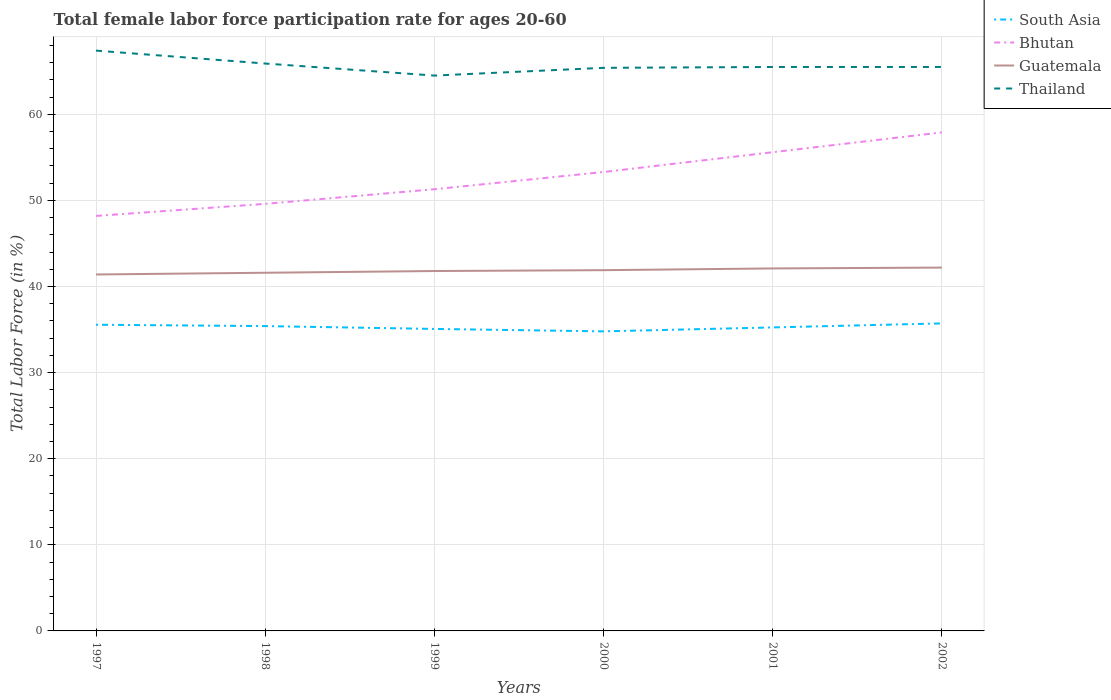How many different coloured lines are there?
Your answer should be compact. 4. Is the number of lines equal to the number of legend labels?
Your answer should be very brief. Yes. Across all years, what is the maximum female labor force participation rate in Bhutan?
Offer a very short reply. 48.2. What is the total female labor force participation rate in South Asia in the graph?
Make the answer very short. -0.18. What is the difference between the highest and the second highest female labor force participation rate in South Asia?
Offer a terse response. 0.92. What is the difference between the highest and the lowest female labor force participation rate in Thailand?
Keep it short and to the point. 2. Is the female labor force participation rate in Thailand strictly greater than the female labor force participation rate in Guatemala over the years?
Your response must be concise. No. Are the values on the major ticks of Y-axis written in scientific E-notation?
Your response must be concise. No. Does the graph contain grids?
Ensure brevity in your answer.  Yes. Where does the legend appear in the graph?
Offer a very short reply. Top right. How many legend labels are there?
Offer a very short reply. 4. How are the legend labels stacked?
Ensure brevity in your answer.  Vertical. What is the title of the graph?
Offer a terse response. Total female labor force participation rate for ages 20-60. What is the label or title of the X-axis?
Your answer should be very brief. Years. What is the Total Labor Force (in %) in South Asia in 1997?
Make the answer very short. 35.56. What is the Total Labor Force (in %) of Bhutan in 1997?
Keep it short and to the point. 48.2. What is the Total Labor Force (in %) in Guatemala in 1997?
Offer a terse response. 41.4. What is the Total Labor Force (in %) of Thailand in 1997?
Your response must be concise. 67.4. What is the Total Labor Force (in %) of South Asia in 1998?
Keep it short and to the point. 35.4. What is the Total Labor Force (in %) of Bhutan in 1998?
Provide a short and direct response. 49.6. What is the Total Labor Force (in %) in Guatemala in 1998?
Offer a terse response. 41.6. What is the Total Labor Force (in %) in Thailand in 1998?
Your response must be concise. 65.9. What is the Total Labor Force (in %) of South Asia in 1999?
Offer a very short reply. 35.07. What is the Total Labor Force (in %) of Bhutan in 1999?
Keep it short and to the point. 51.3. What is the Total Labor Force (in %) in Guatemala in 1999?
Give a very brief answer. 41.8. What is the Total Labor Force (in %) in Thailand in 1999?
Keep it short and to the point. 64.5. What is the Total Labor Force (in %) in South Asia in 2000?
Offer a terse response. 34.79. What is the Total Labor Force (in %) of Bhutan in 2000?
Your response must be concise. 53.3. What is the Total Labor Force (in %) of Guatemala in 2000?
Give a very brief answer. 41.9. What is the Total Labor Force (in %) of Thailand in 2000?
Make the answer very short. 65.4. What is the Total Labor Force (in %) of South Asia in 2001?
Offer a very short reply. 35.25. What is the Total Labor Force (in %) of Bhutan in 2001?
Keep it short and to the point. 55.6. What is the Total Labor Force (in %) of Guatemala in 2001?
Make the answer very short. 42.1. What is the Total Labor Force (in %) of Thailand in 2001?
Ensure brevity in your answer.  65.5. What is the Total Labor Force (in %) of South Asia in 2002?
Make the answer very short. 35.72. What is the Total Labor Force (in %) of Bhutan in 2002?
Offer a terse response. 57.9. What is the Total Labor Force (in %) in Guatemala in 2002?
Keep it short and to the point. 42.2. What is the Total Labor Force (in %) in Thailand in 2002?
Your answer should be very brief. 65.5. Across all years, what is the maximum Total Labor Force (in %) of South Asia?
Provide a short and direct response. 35.72. Across all years, what is the maximum Total Labor Force (in %) in Bhutan?
Your response must be concise. 57.9. Across all years, what is the maximum Total Labor Force (in %) in Guatemala?
Ensure brevity in your answer.  42.2. Across all years, what is the maximum Total Labor Force (in %) of Thailand?
Provide a succinct answer. 67.4. Across all years, what is the minimum Total Labor Force (in %) of South Asia?
Make the answer very short. 34.79. Across all years, what is the minimum Total Labor Force (in %) in Bhutan?
Give a very brief answer. 48.2. Across all years, what is the minimum Total Labor Force (in %) in Guatemala?
Offer a very short reply. 41.4. Across all years, what is the minimum Total Labor Force (in %) in Thailand?
Your answer should be very brief. 64.5. What is the total Total Labor Force (in %) of South Asia in the graph?
Offer a terse response. 211.8. What is the total Total Labor Force (in %) in Bhutan in the graph?
Offer a very short reply. 315.9. What is the total Total Labor Force (in %) in Guatemala in the graph?
Your response must be concise. 251. What is the total Total Labor Force (in %) of Thailand in the graph?
Offer a terse response. 394.2. What is the difference between the Total Labor Force (in %) in South Asia in 1997 and that in 1998?
Ensure brevity in your answer.  0.16. What is the difference between the Total Labor Force (in %) of Guatemala in 1997 and that in 1998?
Give a very brief answer. -0.2. What is the difference between the Total Labor Force (in %) in Thailand in 1997 and that in 1998?
Offer a terse response. 1.5. What is the difference between the Total Labor Force (in %) in South Asia in 1997 and that in 1999?
Your answer should be very brief. 0.49. What is the difference between the Total Labor Force (in %) of Guatemala in 1997 and that in 1999?
Ensure brevity in your answer.  -0.4. What is the difference between the Total Labor Force (in %) in Thailand in 1997 and that in 1999?
Offer a very short reply. 2.9. What is the difference between the Total Labor Force (in %) of South Asia in 1997 and that in 2000?
Make the answer very short. 0.77. What is the difference between the Total Labor Force (in %) of Guatemala in 1997 and that in 2000?
Offer a terse response. -0.5. What is the difference between the Total Labor Force (in %) of South Asia in 1997 and that in 2001?
Your response must be concise. 0.31. What is the difference between the Total Labor Force (in %) in Bhutan in 1997 and that in 2001?
Make the answer very short. -7.4. What is the difference between the Total Labor Force (in %) in Guatemala in 1997 and that in 2001?
Keep it short and to the point. -0.7. What is the difference between the Total Labor Force (in %) of South Asia in 1997 and that in 2002?
Provide a short and direct response. -0.16. What is the difference between the Total Labor Force (in %) in Bhutan in 1997 and that in 2002?
Your answer should be compact. -9.7. What is the difference between the Total Labor Force (in %) of Thailand in 1997 and that in 2002?
Ensure brevity in your answer.  1.9. What is the difference between the Total Labor Force (in %) of South Asia in 1998 and that in 1999?
Keep it short and to the point. 0.33. What is the difference between the Total Labor Force (in %) of Bhutan in 1998 and that in 1999?
Keep it short and to the point. -1.7. What is the difference between the Total Labor Force (in %) of Thailand in 1998 and that in 1999?
Ensure brevity in your answer.  1.4. What is the difference between the Total Labor Force (in %) of South Asia in 1998 and that in 2000?
Your answer should be very brief. 0.61. What is the difference between the Total Labor Force (in %) in Bhutan in 1998 and that in 2000?
Ensure brevity in your answer.  -3.7. What is the difference between the Total Labor Force (in %) of Guatemala in 1998 and that in 2000?
Ensure brevity in your answer.  -0.3. What is the difference between the Total Labor Force (in %) of South Asia in 1998 and that in 2001?
Give a very brief answer. 0.15. What is the difference between the Total Labor Force (in %) of Bhutan in 1998 and that in 2001?
Make the answer very short. -6. What is the difference between the Total Labor Force (in %) of Thailand in 1998 and that in 2001?
Provide a short and direct response. 0.4. What is the difference between the Total Labor Force (in %) of South Asia in 1998 and that in 2002?
Offer a terse response. -0.31. What is the difference between the Total Labor Force (in %) of Bhutan in 1998 and that in 2002?
Offer a very short reply. -8.3. What is the difference between the Total Labor Force (in %) of South Asia in 1999 and that in 2000?
Ensure brevity in your answer.  0.28. What is the difference between the Total Labor Force (in %) in Thailand in 1999 and that in 2000?
Make the answer very short. -0.9. What is the difference between the Total Labor Force (in %) in South Asia in 1999 and that in 2001?
Your answer should be compact. -0.17. What is the difference between the Total Labor Force (in %) in Guatemala in 1999 and that in 2001?
Your response must be concise. -0.3. What is the difference between the Total Labor Force (in %) in Thailand in 1999 and that in 2001?
Your answer should be very brief. -1. What is the difference between the Total Labor Force (in %) of South Asia in 1999 and that in 2002?
Your response must be concise. -0.64. What is the difference between the Total Labor Force (in %) of South Asia in 2000 and that in 2001?
Offer a terse response. -0.46. What is the difference between the Total Labor Force (in %) in Bhutan in 2000 and that in 2001?
Your answer should be very brief. -2.3. What is the difference between the Total Labor Force (in %) in South Asia in 2000 and that in 2002?
Your response must be concise. -0.92. What is the difference between the Total Labor Force (in %) of Guatemala in 2000 and that in 2002?
Your answer should be compact. -0.3. What is the difference between the Total Labor Force (in %) in Thailand in 2000 and that in 2002?
Your answer should be compact. -0.1. What is the difference between the Total Labor Force (in %) of South Asia in 2001 and that in 2002?
Keep it short and to the point. -0.47. What is the difference between the Total Labor Force (in %) of Bhutan in 2001 and that in 2002?
Keep it short and to the point. -2.3. What is the difference between the Total Labor Force (in %) of Guatemala in 2001 and that in 2002?
Your response must be concise. -0.1. What is the difference between the Total Labor Force (in %) of Thailand in 2001 and that in 2002?
Your answer should be compact. 0. What is the difference between the Total Labor Force (in %) of South Asia in 1997 and the Total Labor Force (in %) of Bhutan in 1998?
Offer a very short reply. -14.04. What is the difference between the Total Labor Force (in %) of South Asia in 1997 and the Total Labor Force (in %) of Guatemala in 1998?
Ensure brevity in your answer.  -6.04. What is the difference between the Total Labor Force (in %) in South Asia in 1997 and the Total Labor Force (in %) in Thailand in 1998?
Your answer should be compact. -30.34. What is the difference between the Total Labor Force (in %) in Bhutan in 1997 and the Total Labor Force (in %) in Guatemala in 1998?
Make the answer very short. 6.6. What is the difference between the Total Labor Force (in %) in Bhutan in 1997 and the Total Labor Force (in %) in Thailand in 1998?
Your answer should be compact. -17.7. What is the difference between the Total Labor Force (in %) in Guatemala in 1997 and the Total Labor Force (in %) in Thailand in 1998?
Provide a short and direct response. -24.5. What is the difference between the Total Labor Force (in %) of South Asia in 1997 and the Total Labor Force (in %) of Bhutan in 1999?
Provide a short and direct response. -15.74. What is the difference between the Total Labor Force (in %) of South Asia in 1997 and the Total Labor Force (in %) of Guatemala in 1999?
Offer a very short reply. -6.24. What is the difference between the Total Labor Force (in %) of South Asia in 1997 and the Total Labor Force (in %) of Thailand in 1999?
Keep it short and to the point. -28.94. What is the difference between the Total Labor Force (in %) of Bhutan in 1997 and the Total Labor Force (in %) of Thailand in 1999?
Offer a terse response. -16.3. What is the difference between the Total Labor Force (in %) of Guatemala in 1997 and the Total Labor Force (in %) of Thailand in 1999?
Ensure brevity in your answer.  -23.1. What is the difference between the Total Labor Force (in %) of South Asia in 1997 and the Total Labor Force (in %) of Bhutan in 2000?
Provide a succinct answer. -17.74. What is the difference between the Total Labor Force (in %) in South Asia in 1997 and the Total Labor Force (in %) in Guatemala in 2000?
Offer a very short reply. -6.34. What is the difference between the Total Labor Force (in %) of South Asia in 1997 and the Total Labor Force (in %) of Thailand in 2000?
Give a very brief answer. -29.84. What is the difference between the Total Labor Force (in %) of Bhutan in 1997 and the Total Labor Force (in %) of Thailand in 2000?
Provide a short and direct response. -17.2. What is the difference between the Total Labor Force (in %) in Guatemala in 1997 and the Total Labor Force (in %) in Thailand in 2000?
Your answer should be very brief. -24. What is the difference between the Total Labor Force (in %) of South Asia in 1997 and the Total Labor Force (in %) of Bhutan in 2001?
Provide a short and direct response. -20.04. What is the difference between the Total Labor Force (in %) of South Asia in 1997 and the Total Labor Force (in %) of Guatemala in 2001?
Keep it short and to the point. -6.54. What is the difference between the Total Labor Force (in %) of South Asia in 1997 and the Total Labor Force (in %) of Thailand in 2001?
Ensure brevity in your answer.  -29.94. What is the difference between the Total Labor Force (in %) in Bhutan in 1997 and the Total Labor Force (in %) in Thailand in 2001?
Give a very brief answer. -17.3. What is the difference between the Total Labor Force (in %) in Guatemala in 1997 and the Total Labor Force (in %) in Thailand in 2001?
Offer a very short reply. -24.1. What is the difference between the Total Labor Force (in %) in South Asia in 1997 and the Total Labor Force (in %) in Bhutan in 2002?
Your answer should be compact. -22.34. What is the difference between the Total Labor Force (in %) in South Asia in 1997 and the Total Labor Force (in %) in Guatemala in 2002?
Your answer should be compact. -6.64. What is the difference between the Total Labor Force (in %) in South Asia in 1997 and the Total Labor Force (in %) in Thailand in 2002?
Provide a succinct answer. -29.94. What is the difference between the Total Labor Force (in %) in Bhutan in 1997 and the Total Labor Force (in %) in Thailand in 2002?
Your answer should be compact. -17.3. What is the difference between the Total Labor Force (in %) of Guatemala in 1997 and the Total Labor Force (in %) of Thailand in 2002?
Provide a short and direct response. -24.1. What is the difference between the Total Labor Force (in %) in South Asia in 1998 and the Total Labor Force (in %) in Bhutan in 1999?
Ensure brevity in your answer.  -15.9. What is the difference between the Total Labor Force (in %) in South Asia in 1998 and the Total Labor Force (in %) in Guatemala in 1999?
Your answer should be compact. -6.4. What is the difference between the Total Labor Force (in %) of South Asia in 1998 and the Total Labor Force (in %) of Thailand in 1999?
Offer a very short reply. -29.1. What is the difference between the Total Labor Force (in %) of Bhutan in 1998 and the Total Labor Force (in %) of Thailand in 1999?
Ensure brevity in your answer.  -14.9. What is the difference between the Total Labor Force (in %) of Guatemala in 1998 and the Total Labor Force (in %) of Thailand in 1999?
Ensure brevity in your answer.  -22.9. What is the difference between the Total Labor Force (in %) in South Asia in 1998 and the Total Labor Force (in %) in Bhutan in 2000?
Your response must be concise. -17.9. What is the difference between the Total Labor Force (in %) of South Asia in 1998 and the Total Labor Force (in %) of Guatemala in 2000?
Provide a short and direct response. -6.5. What is the difference between the Total Labor Force (in %) in South Asia in 1998 and the Total Labor Force (in %) in Thailand in 2000?
Your answer should be compact. -30. What is the difference between the Total Labor Force (in %) in Bhutan in 1998 and the Total Labor Force (in %) in Guatemala in 2000?
Provide a succinct answer. 7.7. What is the difference between the Total Labor Force (in %) in Bhutan in 1998 and the Total Labor Force (in %) in Thailand in 2000?
Your response must be concise. -15.8. What is the difference between the Total Labor Force (in %) of Guatemala in 1998 and the Total Labor Force (in %) of Thailand in 2000?
Offer a terse response. -23.8. What is the difference between the Total Labor Force (in %) in South Asia in 1998 and the Total Labor Force (in %) in Bhutan in 2001?
Give a very brief answer. -20.2. What is the difference between the Total Labor Force (in %) in South Asia in 1998 and the Total Labor Force (in %) in Guatemala in 2001?
Ensure brevity in your answer.  -6.7. What is the difference between the Total Labor Force (in %) of South Asia in 1998 and the Total Labor Force (in %) of Thailand in 2001?
Give a very brief answer. -30.1. What is the difference between the Total Labor Force (in %) of Bhutan in 1998 and the Total Labor Force (in %) of Thailand in 2001?
Keep it short and to the point. -15.9. What is the difference between the Total Labor Force (in %) of Guatemala in 1998 and the Total Labor Force (in %) of Thailand in 2001?
Make the answer very short. -23.9. What is the difference between the Total Labor Force (in %) in South Asia in 1998 and the Total Labor Force (in %) in Bhutan in 2002?
Keep it short and to the point. -22.5. What is the difference between the Total Labor Force (in %) in South Asia in 1998 and the Total Labor Force (in %) in Guatemala in 2002?
Your answer should be compact. -6.8. What is the difference between the Total Labor Force (in %) of South Asia in 1998 and the Total Labor Force (in %) of Thailand in 2002?
Give a very brief answer. -30.1. What is the difference between the Total Labor Force (in %) in Bhutan in 1998 and the Total Labor Force (in %) in Thailand in 2002?
Keep it short and to the point. -15.9. What is the difference between the Total Labor Force (in %) of Guatemala in 1998 and the Total Labor Force (in %) of Thailand in 2002?
Your response must be concise. -23.9. What is the difference between the Total Labor Force (in %) in South Asia in 1999 and the Total Labor Force (in %) in Bhutan in 2000?
Give a very brief answer. -18.23. What is the difference between the Total Labor Force (in %) of South Asia in 1999 and the Total Labor Force (in %) of Guatemala in 2000?
Your answer should be compact. -6.83. What is the difference between the Total Labor Force (in %) in South Asia in 1999 and the Total Labor Force (in %) in Thailand in 2000?
Give a very brief answer. -30.33. What is the difference between the Total Labor Force (in %) in Bhutan in 1999 and the Total Labor Force (in %) in Thailand in 2000?
Your response must be concise. -14.1. What is the difference between the Total Labor Force (in %) of Guatemala in 1999 and the Total Labor Force (in %) of Thailand in 2000?
Provide a short and direct response. -23.6. What is the difference between the Total Labor Force (in %) in South Asia in 1999 and the Total Labor Force (in %) in Bhutan in 2001?
Give a very brief answer. -20.53. What is the difference between the Total Labor Force (in %) of South Asia in 1999 and the Total Labor Force (in %) of Guatemala in 2001?
Your answer should be compact. -7.03. What is the difference between the Total Labor Force (in %) of South Asia in 1999 and the Total Labor Force (in %) of Thailand in 2001?
Make the answer very short. -30.43. What is the difference between the Total Labor Force (in %) of Guatemala in 1999 and the Total Labor Force (in %) of Thailand in 2001?
Offer a very short reply. -23.7. What is the difference between the Total Labor Force (in %) in South Asia in 1999 and the Total Labor Force (in %) in Bhutan in 2002?
Ensure brevity in your answer.  -22.83. What is the difference between the Total Labor Force (in %) in South Asia in 1999 and the Total Labor Force (in %) in Guatemala in 2002?
Offer a very short reply. -7.13. What is the difference between the Total Labor Force (in %) of South Asia in 1999 and the Total Labor Force (in %) of Thailand in 2002?
Offer a very short reply. -30.43. What is the difference between the Total Labor Force (in %) in Bhutan in 1999 and the Total Labor Force (in %) in Guatemala in 2002?
Offer a terse response. 9.1. What is the difference between the Total Labor Force (in %) of Guatemala in 1999 and the Total Labor Force (in %) of Thailand in 2002?
Offer a very short reply. -23.7. What is the difference between the Total Labor Force (in %) of South Asia in 2000 and the Total Labor Force (in %) of Bhutan in 2001?
Give a very brief answer. -20.81. What is the difference between the Total Labor Force (in %) of South Asia in 2000 and the Total Labor Force (in %) of Guatemala in 2001?
Provide a short and direct response. -7.31. What is the difference between the Total Labor Force (in %) of South Asia in 2000 and the Total Labor Force (in %) of Thailand in 2001?
Your answer should be compact. -30.71. What is the difference between the Total Labor Force (in %) of Bhutan in 2000 and the Total Labor Force (in %) of Thailand in 2001?
Your response must be concise. -12.2. What is the difference between the Total Labor Force (in %) of Guatemala in 2000 and the Total Labor Force (in %) of Thailand in 2001?
Keep it short and to the point. -23.6. What is the difference between the Total Labor Force (in %) in South Asia in 2000 and the Total Labor Force (in %) in Bhutan in 2002?
Offer a terse response. -23.11. What is the difference between the Total Labor Force (in %) in South Asia in 2000 and the Total Labor Force (in %) in Guatemala in 2002?
Your answer should be very brief. -7.41. What is the difference between the Total Labor Force (in %) of South Asia in 2000 and the Total Labor Force (in %) of Thailand in 2002?
Your answer should be compact. -30.71. What is the difference between the Total Labor Force (in %) in Bhutan in 2000 and the Total Labor Force (in %) in Guatemala in 2002?
Offer a terse response. 11.1. What is the difference between the Total Labor Force (in %) in Guatemala in 2000 and the Total Labor Force (in %) in Thailand in 2002?
Offer a terse response. -23.6. What is the difference between the Total Labor Force (in %) in South Asia in 2001 and the Total Labor Force (in %) in Bhutan in 2002?
Give a very brief answer. -22.65. What is the difference between the Total Labor Force (in %) of South Asia in 2001 and the Total Labor Force (in %) of Guatemala in 2002?
Offer a terse response. -6.95. What is the difference between the Total Labor Force (in %) of South Asia in 2001 and the Total Labor Force (in %) of Thailand in 2002?
Make the answer very short. -30.25. What is the difference between the Total Labor Force (in %) of Bhutan in 2001 and the Total Labor Force (in %) of Guatemala in 2002?
Offer a very short reply. 13.4. What is the difference between the Total Labor Force (in %) of Bhutan in 2001 and the Total Labor Force (in %) of Thailand in 2002?
Your answer should be very brief. -9.9. What is the difference between the Total Labor Force (in %) of Guatemala in 2001 and the Total Labor Force (in %) of Thailand in 2002?
Offer a very short reply. -23.4. What is the average Total Labor Force (in %) of South Asia per year?
Your response must be concise. 35.3. What is the average Total Labor Force (in %) of Bhutan per year?
Keep it short and to the point. 52.65. What is the average Total Labor Force (in %) in Guatemala per year?
Give a very brief answer. 41.83. What is the average Total Labor Force (in %) in Thailand per year?
Make the answer very short. 65.7. In the year 1997, what is the difference between the Total Labor Force (in %) of South Asia and Total Labor Force (in %) of Bhutan?
Your response must be concise. -12.64. In the year 1997, what is the difference between the Total Labor Force (in %) of South Asia and Total Labor Force (in %) of Guatemala?
Give a very brief answer. -5.84. In the year 1997, what is the difference between the Total Labor Force (in %) of South Asia and Total Labor Force (in %) of Thailand?
Offer a very short reply. -31.84. In the year 1997, what is the difference between the Total Labor Force (in %) of Bhutan and Total Labor Force (in %) of Guatemala?
Keep it short and to the point. 6.8. In the year 1997, what is the difference between the Total Labor Force (in %) of Bhutan and Total Labor Force (in %) of Thailand?
Your answer should be compact. -19.2. In the year 1997, what is the difference between the Total Labor Force (in %) of Guatemala and Total Labor Force (in %) of Thailand?
Provide a short and direct response. -26. In the year 1998, what is the difference between the Total Labor Force (in %) of South Asia and Total Labor Force (in %) of Bhutan?
Your answer should be very brief. -14.2. In the year 1998, what is the difference between the Total Labor Force (in %) in South Asia and Total Labor Force (in %) in Guatemala?
Ensure brevity in your answer.  -6.2. In the year 1998, what is the difference between the Total Labor Force (in %) in South Asia and Total Labor Force (in %) in Thailand?
Ensure brevity in your answer.  -30.5. In the year 1998, what is the difference between the Total Labor Force (in %) in Bhutan and Total Labor Force (in %) in Guatemala?
Make the answer very short. 8. In the year 1998, what is the difference between the Total Labor Force (in %) in Bhutan and Total Labor Force (in %) in Thailand?
Provide a succinct answer. -16.3. In the year 1998, what is the difference between the Total Labor Force (in %) in Guatemala and Total Labor Force (in %) in Thailand?
Offer a terse response. -24.3. In the year 1999, what is the difference between the Total Labor Force (in %) of South Asia and Total Labor Force (in %) of Bhutan?
Ensure brevity in your answer.  -16.23. In the year 1999, what is the difference between the Total Labor Force (in %) in South Asia and Total Labor Force (in %) in Guatemala?
Provide a short and direct response. -6.73. In the year 1999, what is the difference between the Total Labor Force (in %) of South Asia and Total Labor Force (in %) of Thailand?
Give a very brief answer. -29.43. In the year 1999, what is the difference between the Total Labor Force (in %) of Bhutan and Total Labor Force (in %) of Guatemala?
Your response must be concise. 9.5. In the year 1999, what is the difference between the Total Labor Force (in %) in Bhutan and Total Labor Force (in %) in Thailand?
Ensure brevity in your answer.  -13.2. In the year 1999, what is the difference between the Total Labor Force (in %) of Guatemala and Total Labor Force (in %) of Thailand?
Give a very brief answer. -22.7. In the year 2000, what is the difference between the Total Labor Force (in %) in South Asia and Total Labor Force (in %) in Bhutan?
Provide a succinct answer. -18.51. In the year 2000, what is the difference between the Total Labor Force (in %) in South Asia and Total Labor Force (in %) in Guatemala?
Your answer should be very brief. -7.11. In the year 2000, what is the difference between the Total Labor Force (in %) of South Asia and Total Labor Force (in %) of Thailand?
Provide a short and direct response. -30.61. In the year 2000, what is the difference between the Total Labor Force (in %) of Bhutan and Total Labor Force (in %) of Thailand?
Keep it short and to the point. -12.1. In the year 2000, what is the difference between the Total Labor Force (in %) of Guatemala and Total Labor Force (in %) of Thailand?
Ensure brevity in your answer.  -23.5. In the year 2001, what is the difference between the Total Labor Force (in %) of South Asia and Total Labor Force (in %) of Bhutan?
Provide a short and direct response. -20.35. In the year 2001, what is the difference between the Total Labor Force (in %) in South Asia and Total Labor Force (in %) in Guatemala?
Offer a very short reply. -6.85. In the year 2001, what is the difference between the Total Labor Force (in %) of South Asia and Total Labor Force (in %) of Thailand?
Ensure brevity in your answer.  -30.25. In the year 2001, what is the difference between the Total Labor Force (in %) of Bhutan and Total Labor Force (in %) of Guatemala?
Your response must be concise. 13.5. In the year 2001, what is the difference between the Total Labor Force (in %) in Bhutan and Total Labor Force (in %) in Thailand?
Provide a short and direct response. -9.9. In the year 2001, what is the difference between the Total Labor Force (in %) in Guatemala and Total Labor Force (in %) in Thailand?
Your response must be concise. -23.4. In the year 2002, what is the difference between the Total Labor Force (in %) in South Asia and Total Labor Force (in %) in Bhutan?
Give a very brief answer. -22.18. In the year 2002, what is the difference between the Total Labor Force (in %) in South Asia and Total Labor Force (in %) in Guatemala?
Keep it short and to the point. -6.48. In the year 2002, what is the difference between the Total Labor Force (in %) of South Asia and Total Labor Force (in %) of Thailand?
Your answer should be compact. -29.78. In the year 2002, what is the difference between the Total Labor Force (in %) of Guatemala and Total Labor Force (in %) of Thailand?
Offer a terse response. -23.3. What is the ratio of the Total Labor Force (in %) of South Asia in 1997 to that in 1998?
Offer a terse response. 1. What is the ratio of the Total Labor Force (in %) in Bhutan in 1997 to that in 1998?
Offer a very short reply. 0.97. What is the ratio of the Total Labor Force (in %) in Thailand in 1997 to that in 1998?
Your response must be concise. 1.02. What is the ratio of the Total Labor Force (in %) in South Asia in 1997 to that in 1999?
Give a very brief answer. 1.01. What is the ratio of the Total Labor Force (in %) of Bhutan in 1997 to that in 1999?
Keep it short and to the point. 0.94. What is the ratio of the Total Labor Force (in %) in Guatemala in 1997 to that in 1999?
Your response must be concise. 0.99. What is the ratio of the Total Labor Force (in %) of Thailand in 1997 to that in 1999?
Your answer should be very brief. 1.04. What is the ratio of the Total Labor Force (in %) of South Asia in 1997 to that in 2000?
Make the answer very short. 1.02. What is the ratio of the Total Labor Force (in %) in Bhutan in 1997 to that in 2000?
Keep it short and to the point. 0.9. What is the ratio of the Total Labor Force (in %) of Thailand in 1997 to that in 2000?
Provide a succinct answer. 1.03. What is the ratio of the Total Labor Force (in %) in South Asia in 1997 to that in 2001?
Make the answer very short. 1.01. What is the ratio of the Total Labor Force (in %) in Bhutan in 1997 to that in 2001?
Provide a succinct answer. 0.87. What is the ratio of the Total Labor Force (in %) in Guatemala in 1997 to that in 2001?
Provide a short and direct response. 0.98. What is the ratio of the Total Labor Force (in %) of South Asia in 1997 to that in 2002?
Ensure brevity in your answer.  1. What is the ratio of the Total Labor Force (in %) in Bhutan in 1997 to that in 2002?
Provide a succinct answer. 0.83. What is the ratio of the Total Labor Force (in %) in Thailand in 1997 to that in 2002?
Your answer should be compact. 1.03. What is the ratio of the Total Labor Force (in %) in South Asia in 1998 to that in 1999?
Provide a succinct answer. 1.01. What is the ratio of the Total Labor Force (in %) in Bhutan in 1998 to that in 1999?
Provide a succinct answer. 0.97. What is the ratio of the Total Labor Force (in %) of Guatemala in 1998 to that in 1999?
Your answer should be very brief. 1. What is the ratio of the Total Labor Force (in %) of Thailand in 1998 to that in 1999?
Make the answer very short. 1.02. What is the ratio of the Total Labor Force (in %) of South Asia in 1998 to that in 2000?
Provide a short and direct response. 1.02. What is the ratio of the Total Labor Force (in %) in Bhutan in 1998 to that in 2000?
Make the answer very short. 0.93. What is the ratio of the Total Labor Force (in %) of Guatemala in 1998 to that in 2000?
Give a very brief answer. 0.99. What is the ratio of the Total Labor Force (in %) in Thailand in 1998 to that in 2000?
Ensure brevity in your answer.  1.01. What is the ratio of the Total Labor Force (in %) in Bhutan in 1998 to that in 2001?
Make the answer very short. 0.89. What is the ratio of the Total Labor Force (in %) in Thailand in 1998 to that in 2001?
Provide a short and direct response. 1.01. What is the ratio of the Total Labor Force (in %) in Bhutan in 1998 to that in 2002?
Provide a short and direct response. 0.86. What is the ratio of the Total Labor Force (in %) in Guatemala in 1998 to that in 2002?
Make the answer very short. 0.99. What is the ratio of the Total Labor Force (in %) in Thailand in 1998 to that in 2002?
Make the answer very short. 1.01. What is the ratio of the Total Labor Force (in %) of South Asia in 1999 to that in 2000?
Make the answer very short. 1.01. What is the ratio of the Total Labor Force (in %) in Bhutan in 1999 to that in 2000?
Provide a short and direct response. 0.96. What is the ratio of the Total Labor Force (in %) of Guatemala in 1999 to that in 2000?
Give a very brief answer. 1. What is the ratio of the Total Labor Force (in %) in Thailand in 1999 to that in 2000?
Offer a terse response. 0.99. What is the ratio of the Total Labor Force (in %) in South Asia in 1999 to that in 2001?
Offer a very short reply. 0.99. What is the ratio of the Total Labor Force (in %) of Bhutan in 1999 to that in 2001?
Make the answer very short. 0.92. What is the ratio of the Total Labor Force (in %) in Thailand in 1999 to that in 2001?
Make the answer very short. 0.98. What is the ratio of the Total Labor Force (in %) in South Asia in 1999 to that in 2002?
Provide a succinct answer. 0.98. What is the ratio of the Total Labor Force (in %) in Bhutan in 1999 to that in 2002?
Give a very brief answer. 0.89. What is the ratio of the Total Labor Force (in %) in Thailand in 1999 to that in 2002?
Make the answer very short. 0.98. What is the ratio of the Total Labor Force (in %) of South Asia in 2000 to that in 2001?
Your answer should be compact. 0.99. What is the ratio of the Total Labor Force (in %) in Bhutan in 2000 to that in 2001?
Give a very brief answer. 0.96. What is the ratio of the Total Labor Force (in %) of Guatemala in 2000 to that in 2001?
Keep it short and to the point. 1. What is the ratio of the Total Labor Force (in %) in Thailand in 2000 to that in 2001?
Give a very brief answer. 1. What is the ratio of the Total Labor Force (in %) in South Asia in 2000 to that in 2002?
Provide a short and direct response. 0.97. What is the ratio of the Total Labor Force (in %) in Bhutan in 2000 to that in 2002?
Provide a short and direct response. 0.92. What is the ratio of the Total Labor Force (in %) in Guatemala in 2000 to that in 2002?
Keep it short and to the point. 0.99. What is the ratio of the Total Labor Force (in %) in South Asia in 2001 to that in 2002?
Your answer should be compact. 0.99. What is the ratio of the Total Labor Force (in %) of Bhutan in 2001 to that in 2002?
Provide a short and direct response. 0.96. What is the ratio of the Total Labor Force (in %) of Guatemala in 2001 to that in 2002?
Make the answer very short. 1. What is the ratio of the Total Labor Force (in %) in Thailand in 2001 to that in 2002?
Offer a very short reply. 1. What is the difference between the highest and the second highest Total Labor Force (in %) in South Asia?
Offer a terse response. 0.16. What is the difference between the highest and the second highest Total Labor Force (in %) of Guatemala?
Your response must be concise. 0.1. What is the difference between the highest and the lowest Total Labor Force (in %) of South Asia?
Provide a short and direct response. 0.92. What is the difference between the highest and the lowest Total Labor Force (in %) in Bhutan?
Your answer should be compact. 9.7. 